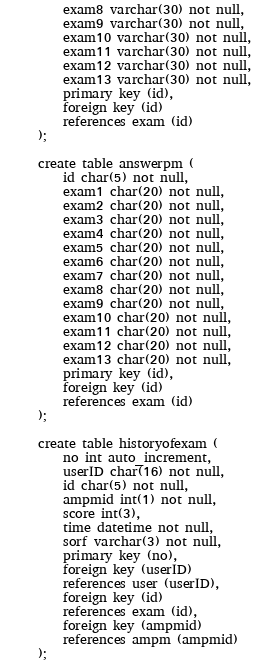Convert code to text. <code><loc_0><loc_0><loc_500><loc_500><_SQL_>	exam8 varchar(30) not null,
	exam9 varchar(30) not null,
	exam10 varchar(30) not null,
	exam11 varchar(30) not null,
	exam12 varchar(30) not null,
	exam13 varchar(30) not null,
	primary key (id),
	foreign key (id)
	references exam (id)
);

create table answerpm (
	id char(5) not null,
	exam1 char(20) not null,
	exam2 char(20) not null,
	exam3 char(20) not null,
	exam4 char(20) not null,
	exam5 char(20) not null,
	exam6 char(20) not null,
	exam7 char(20) not null,
	exam8 char(20) not null,
	exam9 char(20) not null,
	exam10 char(20) not null,
	exam11 char(20) not null,
	exam12 char(20) not null,
	exam13 char(20) not null,
	primary key (id),
	foreign key (id)
	references exam (id)
);

create table historyofexam (
	no int auto_increment,
	userID char(16) not null,
	id char(5) not null,
	ampmid int(1) not null,
	score int(3),
	time datetime not null,
	sorf varchar(3) not null,
	primary key (no),
	foreign key (userID)
	references user (userID),
	foreign key (id)
	references exam (id),
	foreign key (ampmid)
	references ampm (ampmid)
);
</code> 